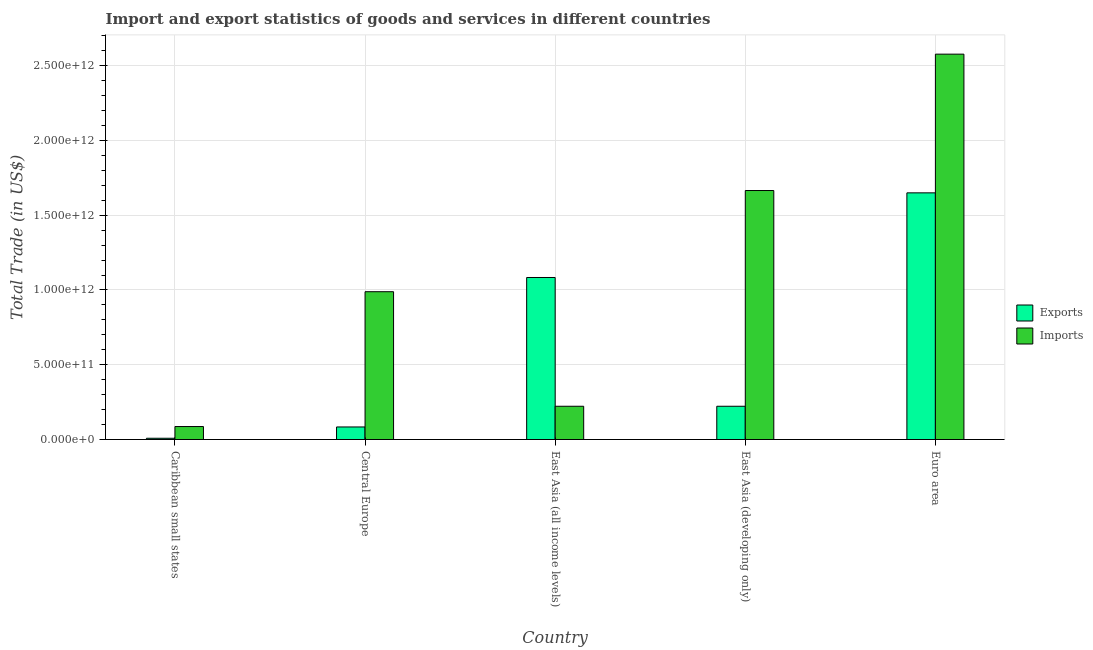How many different coloured bars are there?
Offer a very short reply. 2. Are the number of bars on each tick of the X-axis equal?
Offer a very short reply. Yes. What is the label of the 3rd group of bars from the left?
Offer a terse response. East Asia (all income levels). What is the imports of goods and services in East Asia (developing only)?
Your response must be concise. 1.67e+12. Across all countries, what is the maximum export of goods and services?
Your answer should be very brief. 1.65e+12. Across all countries, what is the minimum export of goods and services?
Your response must be concise. 8.47e+09. In which country was the export of goods and services minimum?
Your response must be concise. Caribbean small states. What is the total export of goods and services in the graph?
Keep it short and to the point. 3.05e+12. What is the difference between the export of goods and services in Caribbean small states and that in Central Europe?
Your response must be concise. -7.55e+1. What is the difference between the export of goods and services in Euro area and the imports of goods and services in East Asia (all income levels)?
Keep it short and to the point. 1.43e+12. What is the average imports of goods and services per country?
Keep it short and to the point. 1.11e+12. What is the difference between the export of goods and services and imports of goods and services in Caribbean small states?
Your answer should be very brief. -7.83e+1. What is the ratio of the export of goods and services in East Asia (all income levels) to that in Euro area?
Give a very brief answer. 0.66. Is the imports of goods and services in East Asia (all income levels) less than that in Euro area?
Your answer should be compact. Yes. What is the difference between the highest and the second highest imports of goods and services?
Provide a short and direct response. 9.12e+11. What is the difference between the highest and the lowest imports of goods and services?
Make the answer very short. 2.49e+12. In how many countries, is the imports of goods and services greater than the average imports of goods and services taken over all countries?
Your answer should be compact. 2. Is the sum of the imports of goods and services in Central Europe and Euro area greater than the maximum export of goods and services across all countries?
Give a very brief answer. Yes. What does the 2nd bar from the left in Euro area represents?
Offer a terse response. Imports. What does the 2nd bar from the right in East Asia (developing only) represents?
Your response must be concise. Exports. How many bars are there?
Ensure brevity in your answer.  10. What is the difference between two consecutive major ticks on the Y-axis?
Your answer should be very brief. 5.00e+11. Are the values on the major ticks of Y-axis written in scientific E-notation?
Provide a short and direct response. Yes. Does the graph contain grids?
Offer a terse response. Yes. Where does the legend appear in the graph?
Provide a succinct answer. Center right. How are the legend labels stacked?
Your answer should be compact. Vertical. What is the title of the graph?
Give a very brief answer. Import and export statistics of goods and services in different countries. Does "Public credit registry" appear as one of the legend labels in the graph?
Ensure brevity in your answer.  No. What is the label or title of the X-axis?
Your answer should be compact. Country. What is the label or title of the Y-axis?
Your answer should be very brief. Total Trade (in US$). What is the Total Trade (in US$) of Exports in Caribbean small states?
Make the answer very short. 8.47e+09. What is the Total Trade (in US$) in Imports in Caribbean small states?
Keep it short and to the point. 8.68e+1. What is the Total Trade (in US$) of Exports in Central Europe?
Your answer should be compact. 8.40e+1. What is the Total Trade (in US$) in Imports in Central Europe?
Offer a very short reply. 9.88e+11. What is the Total Trade (in US$) in Exports in East Asia (all income levels)?
Make the answer very short. 1.08e+12. What is the Total Trade (in US$) of Imports in East Asia (all income levels)?
Provide a short and direct response. 2.22e+11. What is the Total Trade (in US$) in Exports in East Asia (developing only)?
Provide a short and direct response. 2.22e+11. What is the Total Trade (in US$) of Imports in East Asia (developing only)?
Provide a succinct answer. 1.67e+12. What is the Total Trade (in US$) in Exports in Euro area?
Provide a succinct answer. 1.65e+12. What is the Total Trade (in US$) of Imports in Euro area?
Offer a terse response. 2.58e+12. Across all countries, what is the maximum Total Trade (in US$) in Exports?
Make the answer very short. 1.65e+12. Across all countries, what is the maximum Total Trade (in US$) of Imports?
Your response must be concise. 2.58e+12. Across all countries, what is the minimum Total Trade (in US$) of Exports?
Ensure brevity in your answer.  8.47e+09. Across all countries, what is the minimum Total Trade (in US$) in Imports?
Offer a terse response. 8.68e+1. What is the total Total Trade (in US$) of Exports in the graph?
Make the answer very short. 3.05e+12. What is the total Total Trade (in US$) in Imports in the graph?
Your answer should be compact. 5.54e+12. What is the difference between the Total Trade (in US$) of Exports in Caribbean small states and that in Central Europe?
Offer a terse response. -7.55e+1. What is the difference between the Total Trade (in US$) in Imports in Caribbean small states and that in Central Europe?
Keep it short and to the point. -9.02e+11. What is the difference between the Total Trade (in US$) in Exports in Caribbean small states and that in East Asia (all income levels)?
Offer a terse response. -1.08e+12. What is the difference between the Total Trade (in US$) of Imports in Caribbean small states and that in East Asia (all income levels)?
Provide a succinct answer. -1.36e+11. What is the difference between the Total Trade (in US$) of Exports in Caribbean small states and that in East Asia (developing only)?
Your answer should be compact. -2.14e+11. What is the difference between the Total Trade (in US$) in Imports in Caribbean small states and that in East Asia (developing only)?
Provide a succinct answer. -1.58e+12. What is the difference between the Total Trade (in US$) of Exports in Caribbean small states and that in Euro area?
Provide a short and direct response. -1.64e+12. What is the difference between the Total Trade (in US$) in Imports in Caribbean small states and that in Euro area?
Give a very brief answer. -2.49e+12. What is the difference between the Total Trade (in US$) in Exports in Central Europe and that in East Asia (all income levels)?
Make the answer very short. -1.00e+12. What is the difference between the Total Trade (in US$) in Imports in Central Europe and that in East Asia (all income levels)?
Provide a short and direct response. 7.66e+11. What is the difference between the Total Trade (in US$) of Exports in Central Europe and that in East Asia (developing only)?
Provide a short and direct response. -1.38e+11. What is the difference between the Total Trade (in US$) of Imports in Central Europe and that in East Asia (developing only)?
Give a very brief answer. -6.77e+11. What is the difference between the Total Trade (in US$) in Exports in Central Europe and that in Euro area?
Your answer should be very brief. -1.57e+12. What is the difference between the Total Trade (in US$) in Imports in Central Europe and that in Euro area?
Give a very brief answer. -1.59e+12. What is the difference between the Total Trade (in US$) in Exports in East Asia (all income levels) and that in East Asia (developing only)?
Your answer should be very brief. 8.61e+11. What is the difference between the Total Trade (in US$) of Imports in East Asia (all income levels) and that in East Asia (developing only)?
Provide a succinct answer. -1.44e+12. What is the difference between the Total Trade (in US$) of Exports in East Asia (all income levels) and that in Euro area?
Keep it short and to the point. -5.66e+11. What is the difference between the Total Trade (in US$) of Imports in East Asia (all income levels) and that in Euro area?
Offer a terse response. -2.35e+12. What is the difference between the Total Trade (in US$) in Exports in East Asia (developing only) and that in Euro area?
Keep it short and to the point. -1.43e+12. What is the difference between the Total Trade (in US$) in Imports in East Asia (developing only) and that in Euro area?
Provide a short and direct response. -9.12e+11. What is the difference between the Total Trade (in US$) of Exports in Caribbean small states and the Total Trade (in US$) of Imports in Central Europe?
Offer a terse response. -9.80e+11. What is the difference between the Total Trade (in US$) of Exports in Caribbean small states and the Total Trade (in US$) of Imports in East Asia (all income levels)?
Give a very brief answer. -2.14e+11. What is the difference between the Total Trade (in US$) in Exports in Caribbean small states and the Total Trade (in US$) in Imports in East Asia (developing only)?
Provide a succinct answer. -1.66e+12. What is the difference between the Total Trade (in US$) of Exports in Caribbean small states and the Total Trade (in US$) of Imports in Euro area?
Provide a short and direct response. -2.57e+12. What is the difference between the Total Trade (in US$) in Exports in Central Europe and the Total Trade (in US$) in Imports in East Asia (all income levels)?
Keep it short and to the point. -1.38e+11. What is the difference between the Total Trade (in US$) of Exports in Central Europe and the Total Trade (in US$) of Imports in East Asia (developing only)?
Your answer should be compact. -1.58e+12. What is the difference between the Total Trade (in US$) of Exports in Central Europe and the Total Trade (in US$) of Imports in Euro area?
Offer a terse response. -2.49e+12. What is the difference between the Total Trade (in US$) of Exports in East Asia (all income levels) and the Total Trade (in US$) of Imports in East Asia (developing only)?
Offer a very short reply. -5.82e+11. What is the difference between the Total Trade (in US$) of Exports in East Asia (all income levels) and the Total Trade (in US$) of Imports in Euro area?
Offer a terse response. -1.49e+12. What is the difference between the Total Trade (in US$) in Exports in East Asia (developing only) and the Total Trade (in US$) in Imports in Euro area?
Give a very brief answer. -2.35e+12. What is the average Total Trade (in US$) of Exports per country?
Give a very brief answer. 6.10e+11. What is the average Total Trade (in US$) of Imports per country?
Offer a very short reply. 1.11e+12. What is the difference between the Total Trade (in US$) in Exports and Total Trade (in US$) in Imports in Caribbean small states?
Provide a short and direct response. -7.83e+1. What is the difference between the Total Trade (in US$) in Exports and Total Trade (in US$) in Imports in Central Europe?
Keep it short and to the point. -9.04e+11. What is the difference between the Total Trade (in US$) of Exports and Total Trade (in US$) of Imports in East Asia (all income levels)?
Keep it short and to the point. 8.61e+11. What is the difference between the Total Trade (in US$) in Exports and Total Trade (in US$) in Imports in East Asia (developing only)?
Your answer should be very brief. -1.44e+12. What is the difference between the Total Trade (in US$) in Exports and Total Trade (in US$) in Imports in Euro area?
Offer a terse response. -9.28e+11. What is the ratio of the Total Trade (in US$) in Exports in Caribbean small states to that in Central Europe?
Give a very brief answer. 0.1. What is the ratio of the Total Trade (in US$) of Imports in Caribbean small states to that in Central Europe?
Make the answer very short. 0.09. What is the ratio of the Total Trade (in US$) of Exports in Caribbean small states to that in East Asia (all income levels)?
Keep it short and to the point. 0.01. What is the ratio of the Total Trade (in US$) of Imports in Caribbean small states to that in East Asia (all income levels)?
Provide a succinct answer. 0.39. What is the ratio of the Total Trade (in US$) of Exports in Caribbean small states to that in East Asia (developing only)?
Provide a succinct answer. 0.04. What is the ratio of the Total Trade (in US$) in Imports in Caribbean small states to that in East Asia (developing only)?
Your answer should be compact. 0.05. What is the ratio of the Total Trade (in US$) of Exports in Caribbean small states to that in Euro area?
Your answer should be compact. 0.01. What is the ratio of the Total Trade (in US$) in Imports in Caribbean small states to that in Euro area?
Offer a terse response. 0.03. What is the ratio of the Total Trade (in US$) of Exports in Central Europe to that in East Asia (all income levels)?
Your answer should be compact. 0.08. What is the ratio of the Total Trade (in US$) in Imports in Central Europe to that in East Asia (all income levels)?
Offer a very short reply. 4.44. What is the ratio of the Total Trade (in US$) in Exports in Central Europe to that in East Asia (developing only)?
Your response must be concise. 0.38. What is the ratio of the Total Trade (in US$) in Imports in Central Europe to that in East Asia (developing only)?
Keep it short and to the point. 0.59. What is the ratio of the Total Trade (in US$) of Exports in Central Europe to that in Euro area?
Provide a succinct answer. 0.05. What is the ratio of the Total Trade (in US$) of Imports in Central Europe to that in Euro area?
Offer a terse response. 0.38. What is the ratio of the Total Trade (in US$) of Exports in East Asia (all income levels) to that in East Asia (developing only)?
Your response must be concise. 4.87. What is the ratio of the Total Trade (in US$) in Imports in East Asia (all income levels) to that in East Asia (developing only)?
Provide a short and direct response. 0.13. What is the ratio of the Total Trade (in US$) of Exports in East Asia (all income levels) to that in Euro area?
Provide a succinct answer. 0.66. What is the ratio of the Total Trade (in US$) of Imports in East Asia (all income levels) to that in Euro area?
Your answer should be very brief. 0.09. What is the ratio of the Total Trade (in US$) of Exports in East Asia (developing only) to that in Euro area?
Your answer should be very brief. 0.13. What is the ratio of the Total Trade (in US$) of Imports in East Asia (developing only) to that in Euro area?
Offer a terse response. 0.65. What is the difference between the highest and the second highest Total Trade (in US$) of Exports?
Provide a short and direct response. 5.66e+11. What is the difference between the highest and the second highest Total Trade (in US$) in Imports?
Provide a short and direct response. 9.12e+11. What is the difference between the highest and the lowest Total Trade (in US$) of Exports?
Make the answer very short. 1.64e+12. What is the difference between the highest and the lowest Total Trade (in US$) of Imports?
Keep it short and to the point. 2.49e+12. 